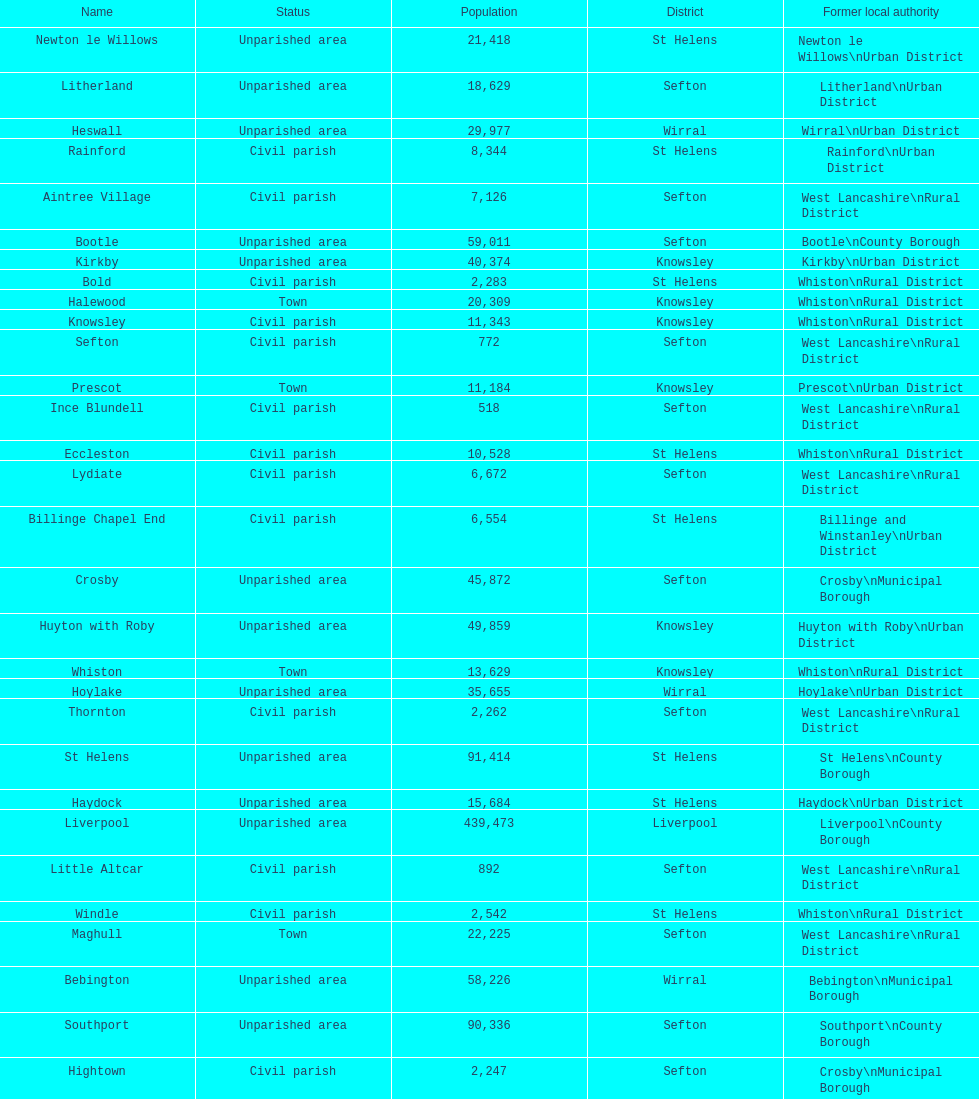Tell me the number of residents in formby. 23,586. 